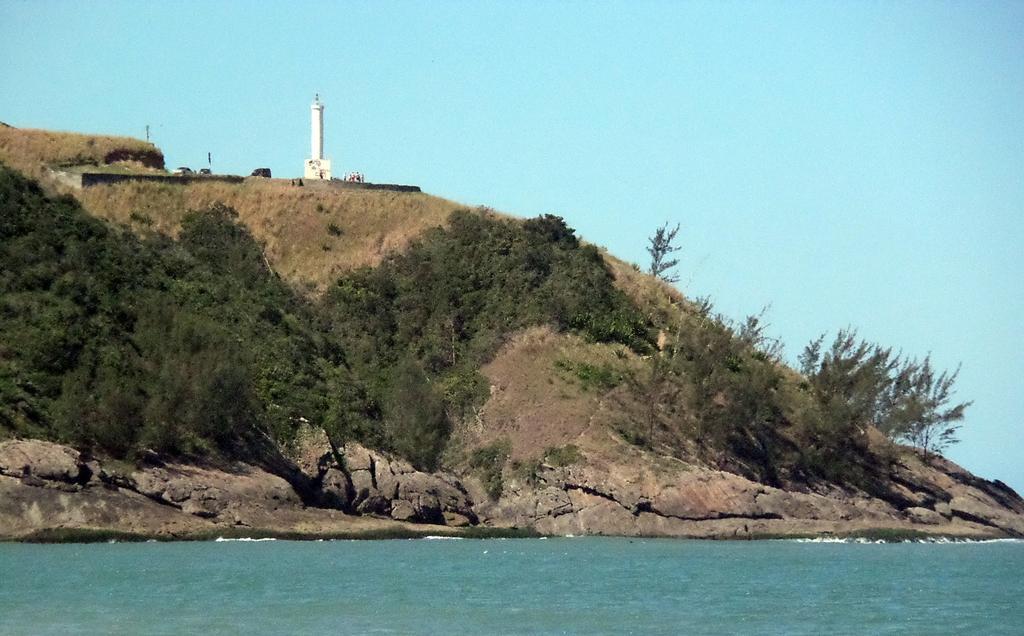Could you give a brief overview of what you see in this image? In this image we can see a tower, a group of people and some poles on the hill. We can also see a group of trees, some plants, a large water body and the sky. 